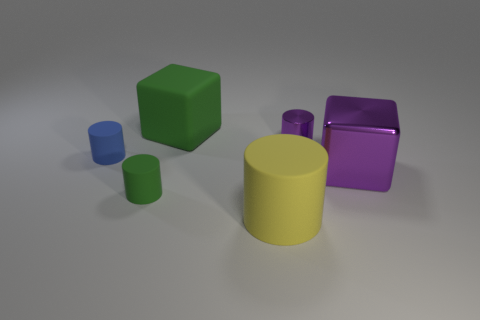Is the metallic cylinder the same color as the shiny cube?
Give a very brief answer. Yes. Are the blue cylinder and the small purple cylinder made of the same material?
Your answer should be compact. No. What is the small blue cylinder made of?
Make the answer very short. Rubber. There is a shiny object left of the big purple block; does it have the same color as the large cube in front of the green matte cube?
Give a very brief answer. Yes. Is the number of metallic cylinders behind the green matte cylinder greater than the number of green metallic objects?
Offer a terse response. Yes. What number of other objects are the same size as the yellow thing?
Make the answer very short. 2. What number of objects are on the left side of the metal block and right of the large yellow rubber cylinder?
Your answer should be very brief. 1. Is the purple object in front of the tiny blue matte cylinder made of the same material as the purple cylinder?
Provide a succinct answer. Yes. What shape is the large matte thing that is behind the rubber thing left of the green matte object in front of the big green matte object?
Ensure brevity in your answer.  Cube. Is the number of tiny green rubber cylinders that are behind the large metallic thing the same as the number of things right of the yellow rubber cylinder?
Give a very brief answer. No. 